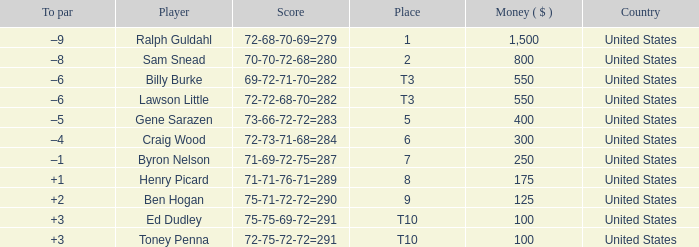Which to par has a prize less than $800? –8. 